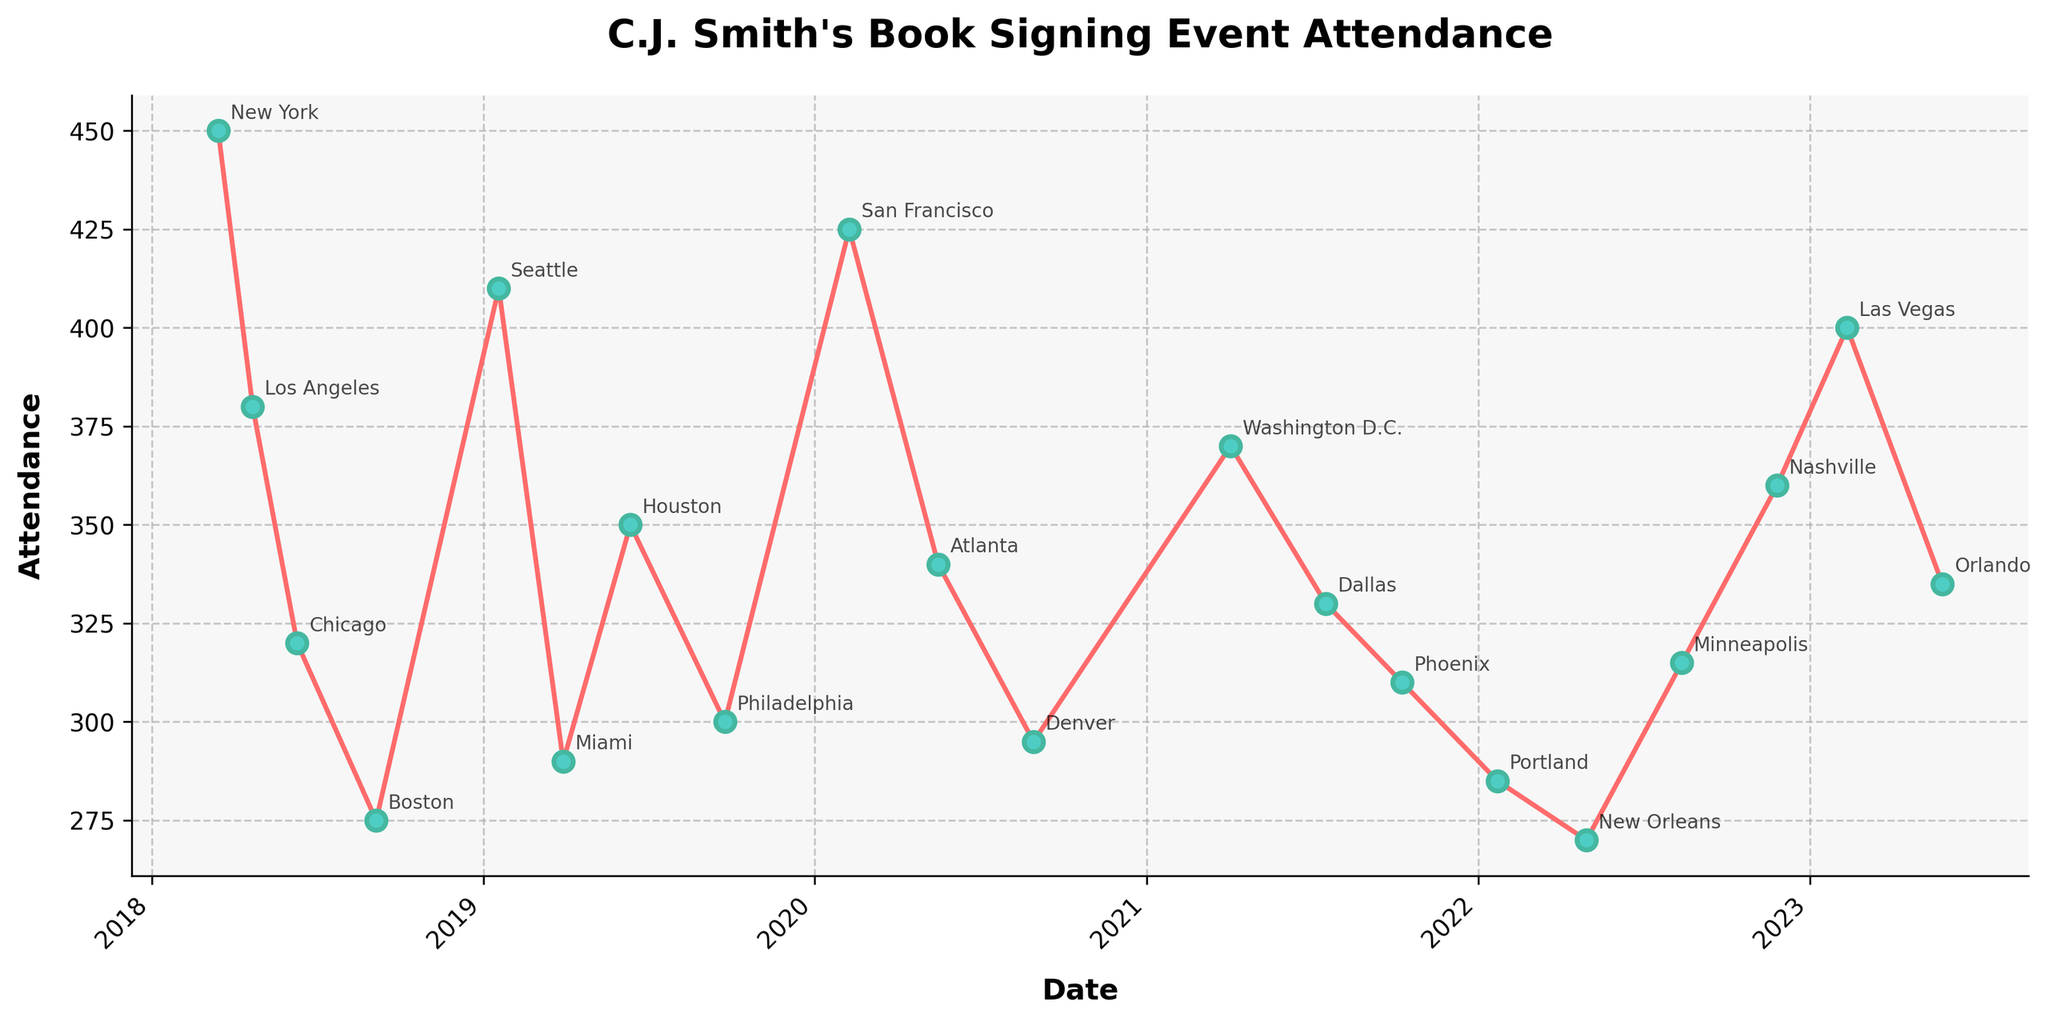Which city had the highest attendance during C.J. Smith's book signing events? To determine the city with the highest attendance, we look for the peak point on the line chart. Here, New York has the highest attendance figure, which is 450 attendees.
Answer: New York Which two cities had their events closest to each other in date, and what were their attendance numbers? To find the closest dates, identify the smallest time gap between two consecutive events. Seattle and Miami had the smallest gap, with their events on 2019-01-18 and 2019-03-30, respectively. Their attendance figures were 410 and 290.
Answer: Seattle (410) and Miami (290) What is the average attendance at C.J. Smith's book signing events over this period? Add up all attendance figures and divide by the number of events: (450 + 380 + 320 + 275 + 410 + 290 + 350 + 300 + 425 + 340 + 295 + 370 + 330 + 310 + 285 + 270 + 315 + 360 + 400 + 335) / 20 = 347.5
Answer: 347.5 Compare the attendance in Seattle and Los Angeles. Which one had a higher count? Locate the points for Seattle and Los Angeles on the chart. Seattle had 410 attendees, while Los Angeles had 380 attendees.
Answer: Seattle Between 2018 and 2020, which city had the lowest attendance at C.J. Smith's book signing events, and what was the number? Identify the events that occurred between 2018 and 2020, then locate the lowest point on the chart within these dates. The lowest attendance was in Boston with 275 attendees.
Answer: Boston, 275 What’s the median attendance figure for these events? Sort the attendance figures and find the middle value. The sorted figures are [270, 275, 285, 290, 295, 300, 310, 315, 320, 330, 335, 340, 350, 360, 370, 380, 400, 410, 425, 450]. The median is between the 10th and 11th values: (330 + 335) / 2 = 332.5
Answer: 332.5 Which city saw the largest drop in attendance from the previous event, and what was the difference? Compare the drops in attendance between consecutive events. The largest drop is from New York to Los Angeles, from 450 to 380, a difference of 450 - 380 = 70.
Answer: Los Angeles, 70 Which consecutive events had the most significant increase in attendance, and what was the increase? Compare increases in attendance between consecutive events. The largest gain is from Miami to Houston, from 290 to 350, an increase of 350 - 290 = 60.
Answer: Houston, 60 How does the attendance in Las Vegas (2023-02-11) compare to the attendance in Washington D.C. (2021-04-03)? Locate the points for Las Vegas and Washington D.C. Las Vegas had 400 attendees, and Washington D.C. had 370 attendees. Thus, Las Vegas had higher attendance.
Answer: Las Vegas 